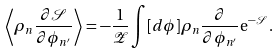<formula> <loc_0><loc_0><loc_500><loc_500>\left \langle \rho _ { n } \frac { \partial \mathcal { S } } { \partial \phi _ { n ^ { \prime } } } \right \rangle = - \frac { 1 } { \mathcal { Z } } \int [ d \phi ] \rho _ { n } \frac { \partial } { \partial \phi _ { n ^ { \prime } } } \mathrm e ^ { - \mathcal { S } } \, .</formula> 